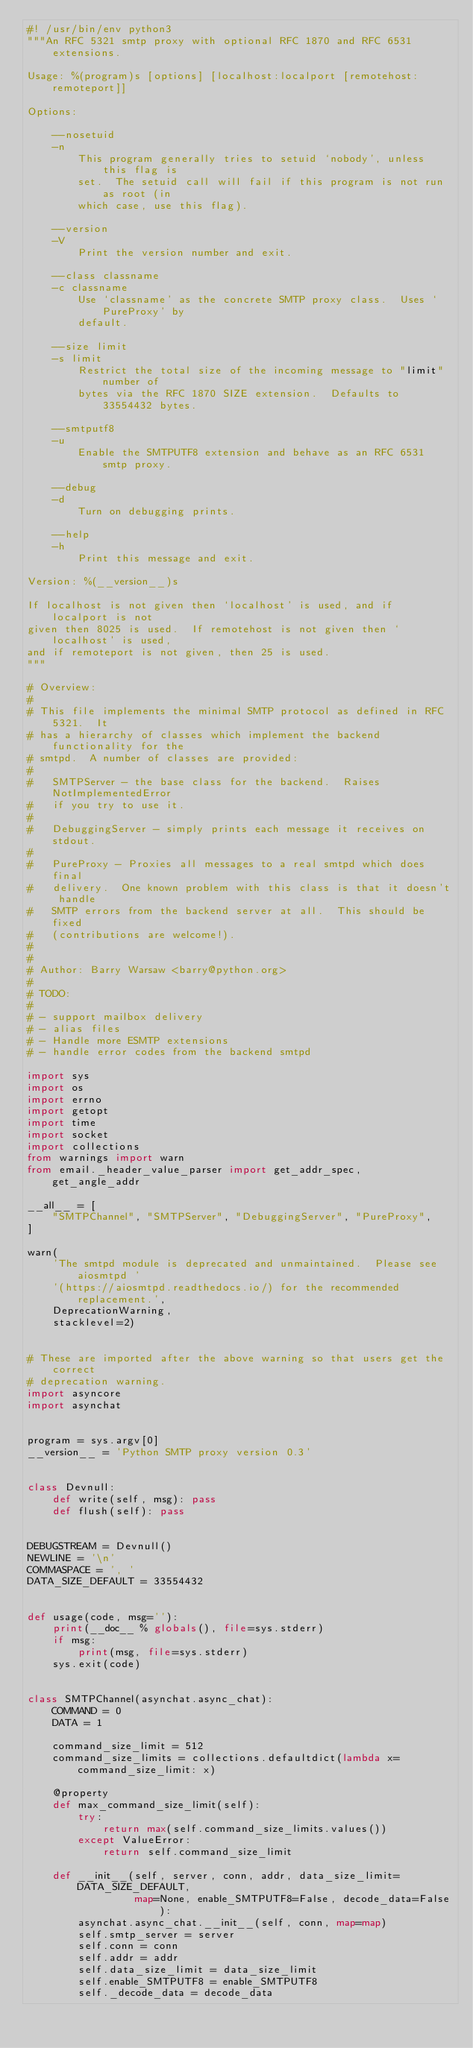<code> <loc_0><loc_0><loc_500><loc_500><_Python_>#! /usr/bin/env python3
"""An RFC 5321 smtp proxy with optional RFC 1870 and RFC 6531 extensions.

Usage: %(program)s [options] [localhost:localport [remotehost:remoteport]]

Options:

    --nosetuid
    -n
        This program generally tries to setuid `nobody', unless this flag is
        set.  The setuid call will fail if this program is not run as root (in
        which case, use this flag).

    --version
    -V
        Print the version number and exit.

    --class classname
    -c classname
        Use `classname' as the concrete SMTP proxy class.  Uses `PureProxy' by
        default.

    --size limit
    -s limit
        Restrict the total size of the incoming message to "limit" number of
        bytes via the RFC 1870 SIZE extension.  Defaults to 33554432 bytes.

    --smtputf8
    -u
        Enable the SMTPUTF8 extension and behave as an RFC 6531 smtp proxy.

    --debug
    -d
        Turn on debugging prints.

    --help
    -h
        Print this message and exit.

Version: %(__version__)s

If localhost is not given then `localhost' is used, and if localport is not
given then 8025 is used.  If remotehost is not given then `localhost' is used,
and if remoteport is not given, then 25 is used.
"""

# Overview:
#
# This file implements the minimal SMTP protocol as defined in RFC 5321.  It
# has a hierarchy of classes which implement the backend functionality for the
# smtpd.  A number of classes are provided:
#
#   SMTPServer - the base class for the backend.  Raises NotImplementedError
#   if you try to use it.
#
#   DebuggingServer - simply prints each message it receives on stdout.
#
#   PureProxy - Proxies all messages to a real smtpd which does final
#   delivery.  One known problem with this class is that it doesn't handle
#   SMTP errors from the backend server at all.  This should be fixed
#   (contributions are welcome!).
#
#
# Author: Barry Warsaw <barry@python.org>
#
# TODO:
#
# - support mailbox delivery
# - alias files
# - Handle more ESMTP extensions
# - handle error codes from the backend smtpd

import sys
import os
import errno
import getopt
import time
import socket
import collections
from warnings import warn
from email._header_value_parser import get_addr_spec, get_angle_addr

__all__ = [
    "SMTPChannel", "SMTPServer", "DebuggingServer", "PureProxy",
]

warn(
    'The smtpd module is deprecated and unmaintained.  Please see aiosmtpd '
    '(https://aiosmtpd.readthedocs.io/) for the recommended replacement.',
    DeprecationWarning,
    stacklevel=2)


# These are imported after the above warning so that users get the correct
# deprecation warning.
import asyncore
import asynchat


program = sys.argv[0]
__version__ = 'Python SMTP proxy version 0.3'


class Devnull:
    def write(self, msg): pass
    def flush(self): pass


DEBUGSTREAM = Devnull()
NEWLINE = '\n'
COMMASPACE = ', '
DATA_SIZE_DEFAULT = 33554432


def usage(code, msg=''):
    print(__doc__ % globals(), file=sys.stderr)
    if msg:
        print(msg, file=sys.stderr)
    sys.exit(code)


class SMTPChannel(asynchat.async_chat):
    COMMAND = 0
    DATA = 1

    command_size_limit = 512
    command_size_limits = collections.defaultdict(lambda x=command_size_limit: x)

    @property
    def max_command_size_limit(self):
        try:
            return max(self.command_size_limits.values())
        except ValueError:
            return self.command_size_limit

    def __init__(self, server, conn, addr, data_size_limit=DATA_SIZE_DEFAULT,
                 map=None, enable_SMTPUTF8=False, decode_data=False):
        asynchat.async_chat.__init__(self, conn, map=map)
        self.smtp_server = server
        self.conn = conn
        self.addr = addr
        self.data_size_limit = data_size_limit
        self.enable_SMTPUTF8 = enable_SMTPUTF8
        self._decode_data = decode_data</code> 